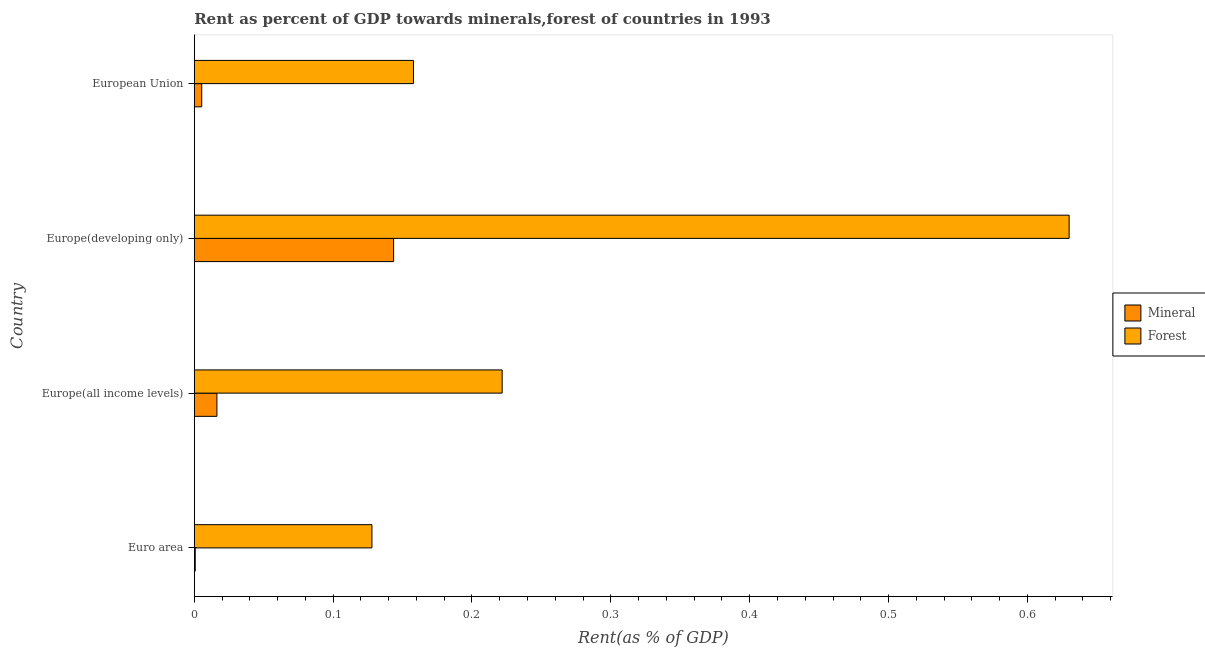How many different coloured bars are there?
Provide a short and direct response. 2. Are the number of bars on each tick of the Y-axis equal?
Give a very brief answer. Yes. How many bars are there on the 1st tick from the top?
Your response must be concise. 2. How many bars are there on the 2nd tick from the bottom?
Provide a succinct answer. 2. What is the label of the 3rd group of bars from the top?
Provide a succinct answer. Europe(all income levels). What is the mineral rent in Europe(all income levels)?
Your answer should be compact. 0.02. Across all countries, what is the maximum forest rent?
Ensure brevity in your answer.  0.63. Across all countries, what is the minimum mineral rent?
Provide a succinct answer. 0. In which country was the mineral rent maximum?
Provide a succinct answer. Europe(developing only). In which country was the mineral rent minimum?
Ensure brevity in your answer.  Euro area. What is the total forest rent in the graph?
Your answer should be very brief. 1.14. What is the difference between the mineral rent in Europe(all income levels) and that in European Union?
Provide a succinct answer. 0.01. What is the difference between the mineral rent in Euro area and the forest rent in European Union?
Provide a short and direct response. -0.16. What is the average forest rent per country?
Ensure brevity in your answer.  0.28. What is the difference between the forest rent and mineral rent in Europe(all income levels)?
Offer a very short reply. 0.2. What is the ratio of the mineral rent in Euro area to that in European Union?
Give a very brief answer. 0.13. What is the difference between the highest and the second highest mineral rent?
Provide a short and direct response. 0.13. What is the difference between the highest and the lowest forest rent?
Give a very brief answer. 0.5. Is the sum of the forest rent in Europe(all income levels) and European Union greater than the maximum mineral rent across all countries?
Offer a terse response. Yes. What does the 1st bar from the top in Europe(all income levels) represents?
Your response must be concise. Forest. What does the 1st bar from the bottom in Europe(developing only) represents?
Your answer should be compact. Mineral. Are all the bars in the graph horizontal?
Your answer should be very brief. Yes. How many countries are there in the graph?
Your answer should be compact. 4. What is the difference between two consecutive major ticks on the X-axis?
Your response must be concise. 0.1. Does the graph contain any zero values?
Give a very brief answer. No. Where does the legend appear in the graph?
Your answer should be very brief. Center right. How many legend labels are there?
Your answer should be compact. 2. How are the legend labels stacked?
Offer a terse response. Vertical. What is the title of the graph?
Make the answer very short. Rent as percent of GDP towards minerals,forest of countries in 1993. Does "2012 US$" appear as one of the legend labels in the graph?
Make the answer very short. No. What is the label or title of the X-axis?
Provide a succinct answer. Rent(as % of GDP). What is the Rent(as % of GDP) in Mineral in Euro area?
Your answer should be very brief. 0. What is the Rent(as % of GDP) of Forest in Euro area?
Your response must be concise. 0.13. What is the Rent(as % of GDP) in Mineral in Europe(all income levels)?
Make the answer very short. 0.02. What is the Rent(as % of GDP) in Forest in Europe(all income levels)?
Offer a very short reply. 0.22. What is the Rent(as % of GDP) of Mineral in Europe(developing only)?
Your answer should be very brief. 0.14. What is the Rent(as % of GDP) in Forest in Europe(developing only)?
Offer a very short reply. 0.63. What is the Rent(as % of GDP) in Mineral in European Union?
Offer a very short reply. 0.01. What is the Rent(as % of GDP) of Forest in European Union?
Your answer should be very brief. 0.16. Across all countries, what is the maximum Rent(as % of GDP) of Mineral?
Your answer should be very brief. 0.14. Across all countries, what is the maximum Rent(as % of GDP) in Forest?
Offer a very short reply. 0.63. Across all countries, what is the minimum Rent(as % of GDP) in Mineral?
Provide a short and direct response. 0. Across all countries, what is the minimum Rent(as % of GDP) in Forest?
Offer a very short reply. 0.13. What is the total Rent(as % of GDP) in Mineral in the graph?
Provide a succinct answer. 0.17. What is the total Rent(as % of GDP) in Forest in the graph?
Make the answer very short. 1.14. What is the difference between the Rent(as % of GDP) in Mineral in Euro area and that in Europe(all income levels)?
Keep it short and to the point. -0.02. What is the difference between the Rent(as % of GDP) of Forest in Euro area and that in Europe(all income levels)?
Make the answer very short. -0.09. What is the difference between the Rent(as % of GDP) of Mineral in Euro area and that in Europe(developing only)?
Give a very brief answer. -0.14. What is the difference between the Rent(as % of GDP) of Forest in Euro area and that in Europe(developing only)?
Give a very brief answer. -0.5. What is the difference between the Rent(as % of GDP) of Mineral in Euro area and that in European Union?
Offer a terse response. -0. What is the difference between the Rent(as % of GDP) in Forest in Euro area and that in European Union?
Keep it short and to the point. -0.03. What is the difference between the Rent(as % of GDP) in Mineral in Europe(all income levels) and that in Europe(developing only)?
Offer a very short reply. -0.13. What is the difference between the Rent(as % of GDP) of Forest in Europe(all income levels) and that in Europe(developing only)?
Ensure brevity in your answer.  -0.41. What is the difference between the Rent(as % of GDP) in Mineral in Europe(all income levels) and that in European Union?
Provide a short and direct response. 0.01. What is the difference between the Rent(as % of GDP) of Forest in Europe(all income levels) and that in European Union?
Provide a short and direct response. 0.06. What is the difference between the Rent(as % of GDP) in Mineral in Europe(developing only) and that in European Union?
Make the answer very short. 0.14. What is the difference between the Rent(as % of GDP) of Forest in Europe(developing only) and that in European Union?
Keep it short and to the point. 0.47. What is the difference between the Rent(as % of GDP) of Mineral in Euro area and the Rent(as % of GDP) of Forest in Europe(all income levels)?
Your response must be concise. -0.22. What is the difference between the Rent(as % of GDP) of Mineral in Euro area and the Rent(as % of GDP) of Forest in Europe(developing only)?
Make the answer very short. -0.63. What is the difference between the Rent(as % of GDP) of Mineral in Euro area and the Rent(as % of GDP) of Forest in European Union?
Keep it short and to the point. -0.16. What is the difference between the Rent(as % of GDP) of Mineral in Europe(all income levels) and the Rent(as % of GDP) of Forest in Europe(developing only)?
Your answer should be very brief. -0.61. What is the difference between the Rent(as % of GDP) in Mineral in Europe(all income levels) and the Rent(as % of GDP) in Forest in European Union?
Your response must be concise. -0.14. What is the difference between the Rent(as % of GDP) of Mineral in Europe(developing only) and the Rent(as % of GDP) of Forest in European Union?
Offer a very short reply. -0.01. What is the average Rent(as % of GDP) of Mineral per country?
Ensure brevity in your answer.  0.04. What is the average Rent(as % of GDP) in Forest per country?
Offer a very short reply. 0.28. What is the difference between the Rent(as % of GDP) of Mineral and Rent(as % of GDP) of Forest in Euro area?
Your response must be concise. -0.13. What is the difference between the Rent(as % of GDP) of Mineral and Rent(as % of GDP) of Forest in Europe(all income levels)?
Give a very brief answer. -0.21. What is the difference between the Rent(as % of GDP) of Mineral and Rent(as % of GDP) of Forest in Europe(developing only)?
Offer a very short reply. -0.49. What is the difference between the Rent(as % of GDP) in Mineral and Rent(as % of GDP) in Forest in European Union?
Give a very brief answer. -0.15. What is the ratio of the Rent(as % of GDP) of Mineral in Euro area to that in Europe(all income levels)?
Provide a short and direct response. 0.04. What is the ratio of the Rent(as % of GDP) of Forest in Euro area to that in Europe(all income levels)?
Give a very brief answer. 0.58. What is the ratio of the Rent(as % of GDP) of Mineral in Euro area to that in Europe(developing only)?
Provide a short and direct response. 0. What is the ratio of the Rent(as % of GDP) in Forest in Euro area to that in Europe(developing only)?
Offer a very short reply. 0.2. What is the ratio of the Rent(as % of GDP) in Mineral in Euro area to that in European Union?
Give a very brief answer. 0.13. What is the ratio of the Rent(as % of GDP) in Forest in Euro area to that in European Union?
Provide a succinct answer. 0.81. What is the ratio of the Rent(as % of GDP) of Mineral in Europe(all income levels) to that in Europe(developing only)?
Provide a succinct answer. 0.11. What is the ratio of the Rent(as % of GDP) in Forest in Europe(all income levels) to that in Europe(developing only)?
Your response must be concise. 0.35. What is the ratio of the Rent(as % of GDP) of Mineral in Europe(all income levels) to that in European Union?
Keep it short and to the point. 3.04. What is the ratio of the Rent(as % of GDP) in Forest in Europe(all income levels) to that in European Union?
Give a very brief answer. 1.4. What is the ratio of the Rent(as % of GDP) in Mineral in Europe(developing only) to that in European Union?
Your answer should be very brief. 26.75. What is the ratio of the Rent(as % of GDP) in Forest in Europe(developing only) to that in European Union?
Give a very brief answer. 3.99. What is the difference between the highest and the second highest Rent(as % of GDP) in Mineral?
Ensure brevity in your answer.  0.13. What is the difference between the highest and the second highest Rent(as % of GDP) of Forest?
Make the answer very short. 0.41. What is the difference between the highest and the lowest Rent(as % of GDP) of Mineral?
Your answer should be very brief. 0.14. What is the difference between the highest and the lowest Rent(as % of GDP) of Forest?
Give a very brief answer. 0.5. 